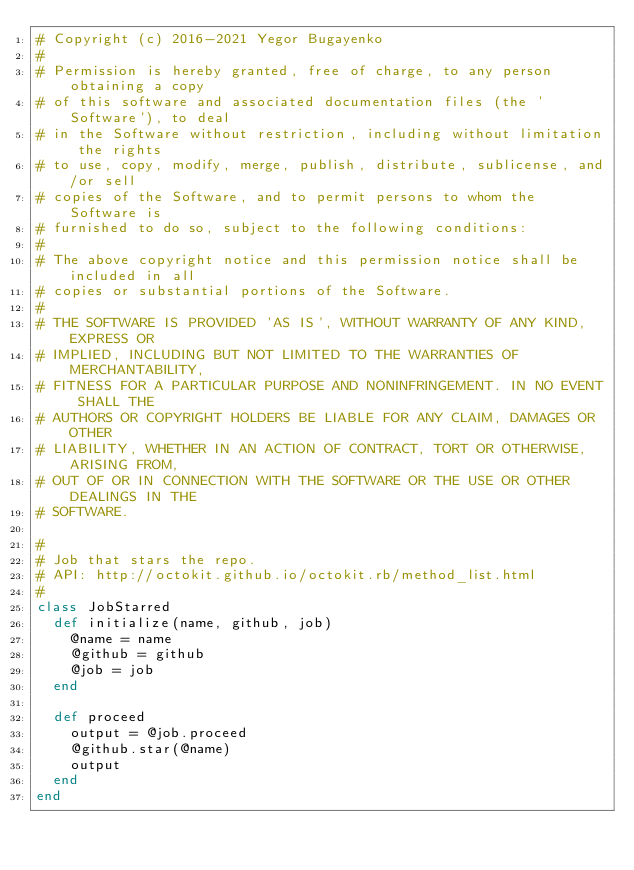<code> <loc_0><loc_0><loc_500><loc_500><_Ruby_># Copyright (c) 2016-2021 Yegor Bugayenko
#
# Permission is hereby granted, free of charge, to any person obtaining a copy
# of this software and associated documentation files (the 'Software'), to deal
# in the Software without restriction, including without limitation the rights
# to use, copy, modify, merge, publish, distribute, sublicense, and/or sell
# copies of the Software, and to permit persons to whom the Software is
# furnished to do so, subject to the following conditions:
#
# The above copyright notice and this permission notice shall be included in all
# copies or substantial portions of the Software.
#
# THE SOFTWARE IS PROVIDED 'AS IS', WITHOUT WARRANTY OF ANY KIND, EXPRESS OR
# IMPLIED, INCLUDING BUT NOT LIMITED TO THE WARRANTIES OF MERCHANTABILITY,
# FITNESS FOR A PARTICULAR PURPOSE AND NONINFRINGEMENT. IN NO EVENT SHALL THE
# AUTHORS OR COPYRIGHT HOLDERS BE LIABLE FOR ANY CLAIM, DAMAGES OR OTHER
# LIABILITY, WHETHER IN AN ACTION OF CONTRACT, TORT OR OTHERWISE, ARISING FROM,
# OUT OF OR IN CONNECTION WITH THE SOFTWARE OR THE USE OR OTHER DEALINGS IN THE
# SOFTWARE.

#
# Job that stars the repo.
# API: http://octokit.github.io/octokit.rb/method_list.html
#
class JobStarred
  def initialize(name, github, job)
    @name = name
    @github = github
    @job = job
  end

  def proceed
    output = @job.proceed
    @github.star(@name)
    output
  end
end
</code> 